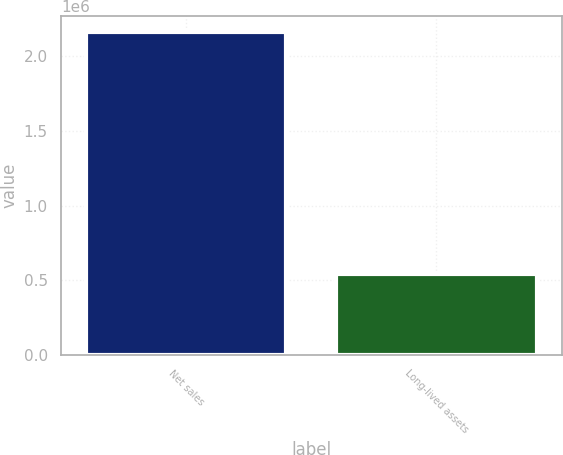Convert chart. <chart><loc_0><loc_0><loc_500><loc_500><bar_chart><fcel>Net sales<fcel>Long-lived assets<nl><fcel>2.15992e+06<fcel>543734<nl></chart> 